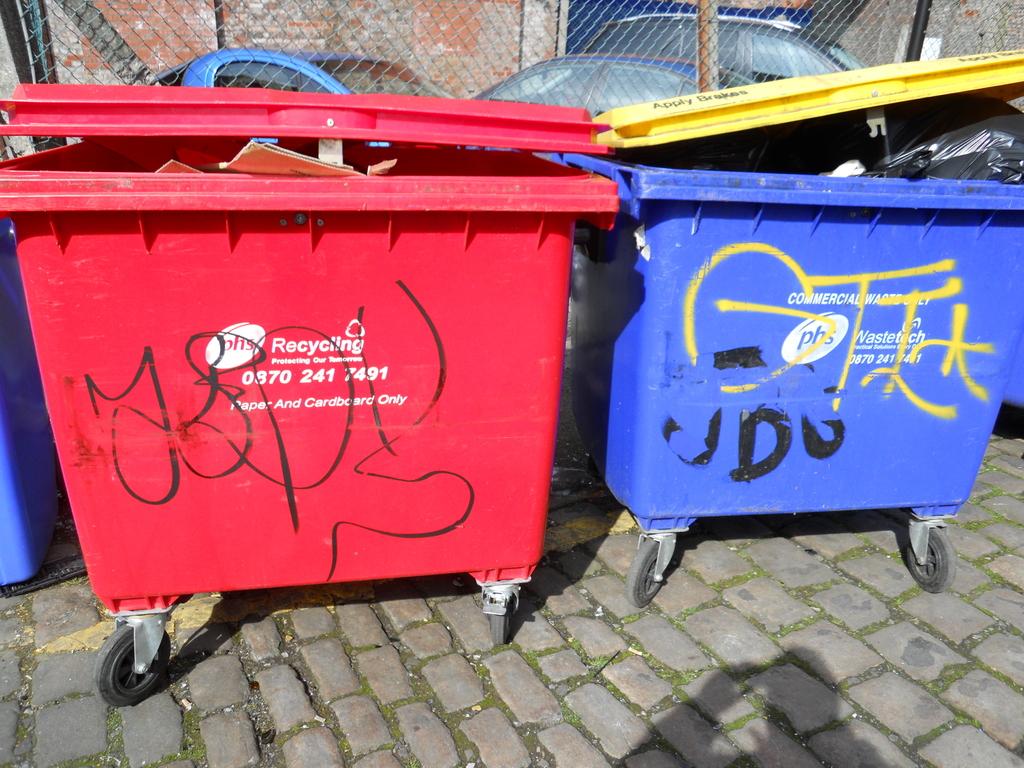What kind of bin is the red bin?
Your answer should be compact. Recycling. Is the red recycling?
Provide a short and direct response. Yes. 